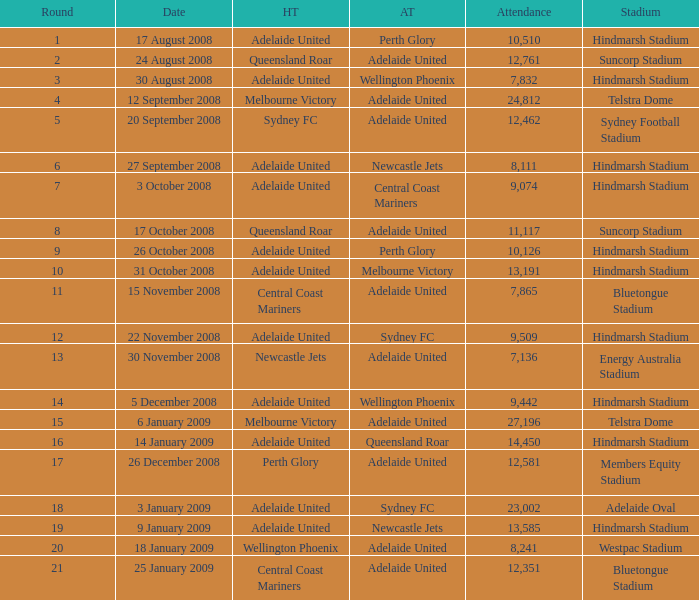Who was the away team when Queensland Roar was the home team in the round less than 3? Adelaide United. 